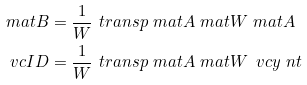<formula> <loc_0><loc_0><loc_500><loc_500>\ m a t B & = \frac { 1 } { W } \ t r a n s p { \ m a t A } \ m a t W \ m a t A \\ \ v c I D & = \frac { 1 } { W } \ t r a n s p { \ m a t A } \ m a t W \, \ v c y \ n t</formula> 